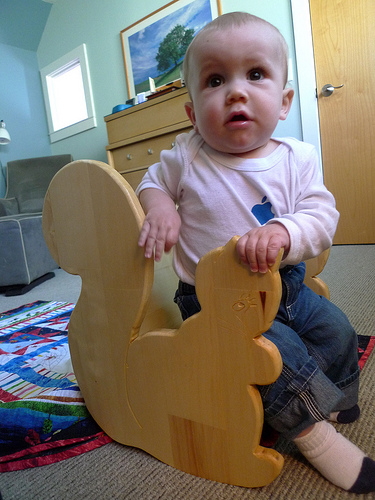<image>
Is there a photo behind the baby? Yes. From this viewpoint, the photo is positioned behind the baby, with the baby partially or fully occluding the photo. 